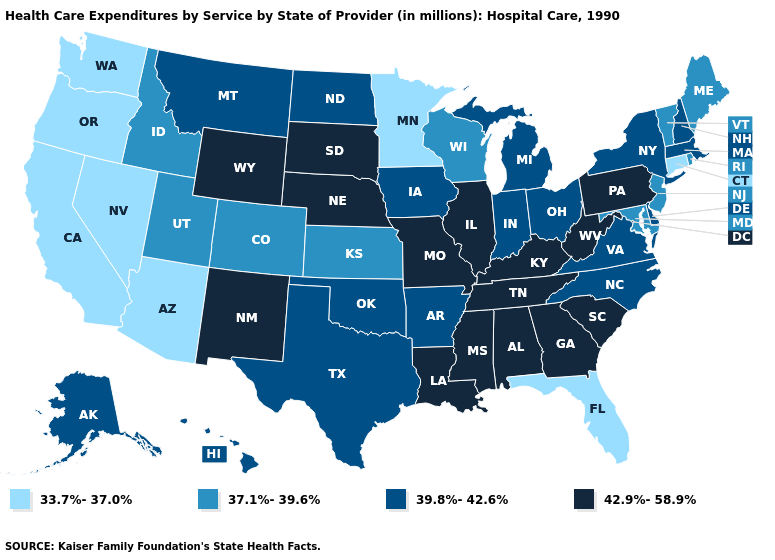What is the lowest value in states that border Oregon?
Write a very short answer. 33.7%-37.0%. Name the states that have a value in the range 39.8%-42.6%?
Write a very short answer. Alaska, Arkansas, Delaware, Hawaii, Indiana, Iowa, Massachusetts, Michigan, Montana, New Hampshire, New York, North Carolina, North Dakota, Ohio, Oklahoma, Texas, Virginia. What is the value of New Jersey?
Be succinct. 37.1%-39.6%. Name the states that have a value in the range 37.1%-39.6%?
Write a very short answer. Colorado, Idaho, Kansas, Maine, Maryland, New Jersey, Rhode Island, Utah, Vermont, Wisconsin. Does Illinois have the highest value in the USA?
Write a very short answer. Yes. Does New Jersey have the highest value in the Northeast?
Quick response, please. No. What is the lowest value in states that border Wyoming?
Short answer required. 37.1%-39.6%. Which states have the highest value in the USA?
Be succinct. Alabama, Georgia, Illinois, Kentucky, Louisiana, Mississippi, Missouri, Nebraska, New Mexico, Pennsylvania, South Carolina, South Dakota, Tennessee, West Virginia, Wyoming. What is the value of Iowa?
Answer briefly. 39.8%-42.6%. Name the states that have a value in the range 42.9%-58.9%?
Answer briefly. Alabama, Georgia, Illinois, Kentucky, Louisiana, Mississippi, Missouri, Nebraska, New Mexico, Pennsylvania, South Carolina, South Dakota, Tennessee, West Virginia, Wyoming. Does the first symbol in the legend represent the smallest category?
Keep it brief. Yes. Does Illinois have a lower value than Utah?
Short answer required. No. Does Arizona have the same value as Oregon?
Write a very short answer. Yes. Which states hav the highest value in the West?
Be succinct. New Mexico, Wyoming. 